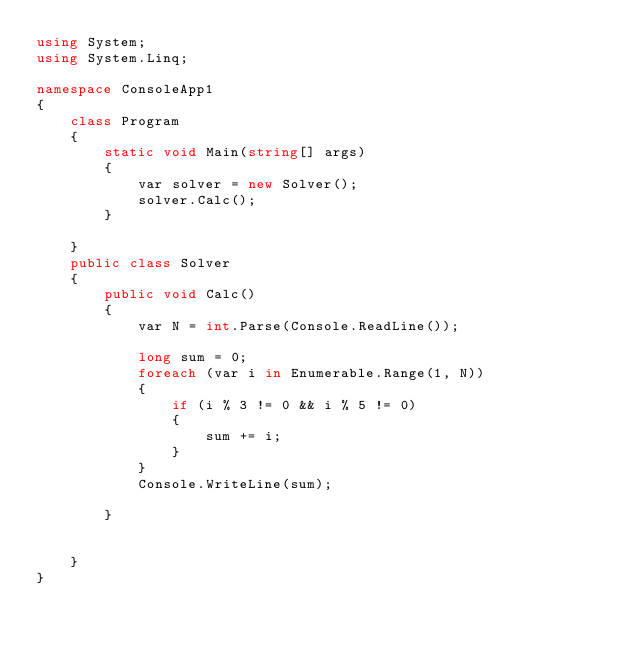Convert code to text. <code><loc_0><loc_0><loc_500><loc_500><_C#_>using System;
using System.Linq;

namespace ConsoleApp1
{
    class Program
    {
        static void Main(string[] args)
        {
            var solver = new Solver();
            solver.Calc();
        }

    }
    public class Solver
    {
        public void Calc()
        {
            var N = int.Parse(Console.ReadLine());

            long sum = 0;
            foreach (var i in Enumerable.Range(1, N))
            {
                if (i % 3 != 0 && i % 5 != 0)
                {
                    sum += i;
                }
            }
            Console.WriteLine(sum);

        }


    }
}
</code> 